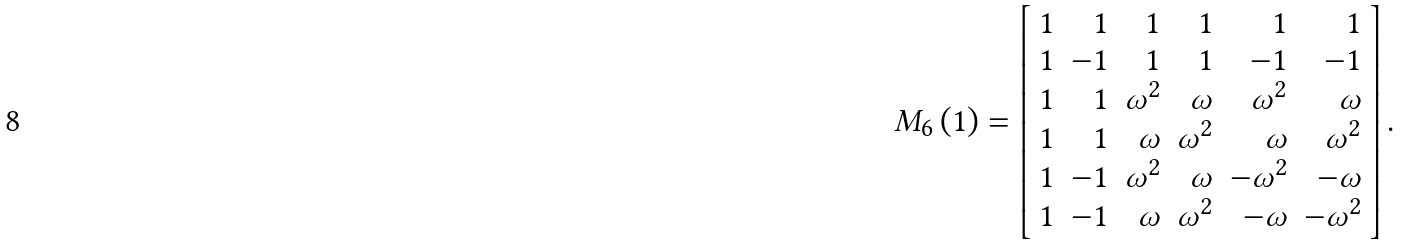Convert formula to latex. <formula><loc_0><loc_0><loc_500><loc_500>M _ { 6 } \left ( 1 \right ) = \left [ \begin{array} { r r r r r r } 1 & 1 & 1 & 1 & 1 & 1 \\ 1 & - 1 & 1 & 1 & - 1 & - 1 \\ 1 & 1 & \omega ^ { 2 } & \omega & \omega ^ { 2 } & \omega \\ 1 & 1 & \omega & \omega ^ { 2 } & \omega & \omega ^ { 2 } \\ 1 & - 1 & \omega ^ { 2 } & \omega & - \omega ^ { 2 } & - \omega \\ 1 & - 1 & \omega & \omega ^ { 2 } & - \omega & - \omega ^ { 2 } \end{array} \right ] .</formula> 